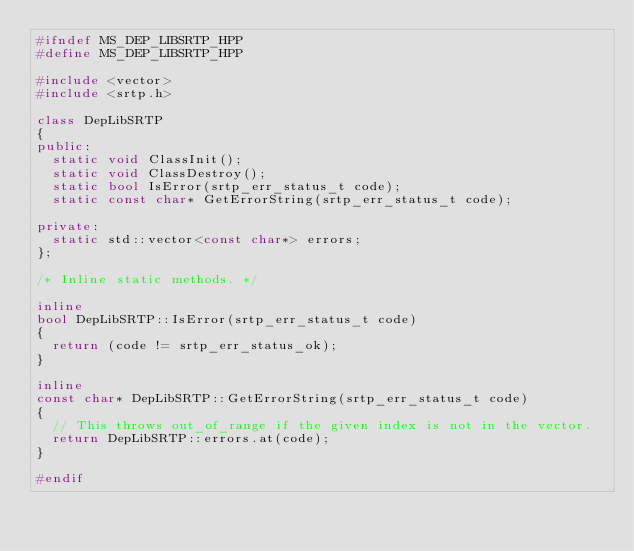Convert code to text. <code><loc_0><loc_0><loc_500><loc_500><_C++_>#ifndef MS_DEP_LIBSRTP_HPP
#define	MS_DEP_LIBSRTP_HPP

#include <vector>
#include <srtp.h>

class DepLibSRTP
{
public:
	static void ClassInit();
	static void ClassDestroy();
	static bool IsError(srtp_err_status_t code);
	static const char* GetErrorString(srtp_err_status_t code);

private:
	static std::vector<const char*> errors;
};

/* Inline static methods. */

inline
bool DepLibSRTP::IsError(srtp_err_status_t code)
{
	return (code != srtp_err_status_ok);
}

inline
const char* DepLibSRTP::GetErrorString(srtp_err_status_t code)
{
	// This throws out_of_range if the given index is not in the vector.
	return DepLibSRTP::errors.at(code);
}

#endif
</code> 